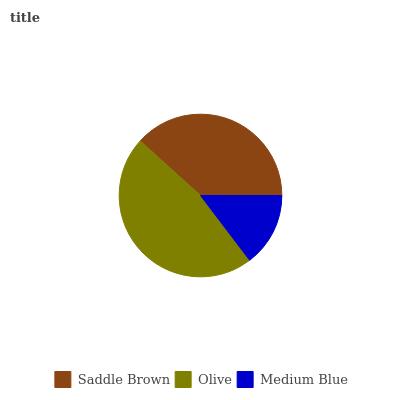Is Medium Blue the minimum?
Answer yes or no. Yes. Is Olive the maximum?
Answer yes or no. Yes. Is Olive the minimum?
Answer yes or no. No. Is Medium Blue the maximum?
Answer yes or no. No. Is Olive greater than Medium Blue?
Answer yes or no. Yes. Is Medium Blue less than Olive?
Answer yes or no. Yes. Is Medium Blue greater than Olive?
Answer yes or no. No. Is Olive less than Medium Blue?
Answer yes or no. No. Is Saddle Brown the high median?
Answer yes or no. Yes. Is Saddle Brown the low median?
Answer yes or no. Yes. Is Medium Blue the high median?
Answer yes or no. No. Is Medium Blue the low median?
Answer yes or no. No. 